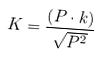<formula> <loc_0><loc_0><loc_500><loc_500>K = \frac { \left ( P \cdot k \right ) } { \sqrt { P ^ { 2 } } }</formula> 